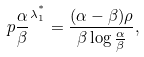<formula> <loc_0><loc_0><loc_500><loc_500>\ p { \frac { \alpha } { \beta } } ^ { \lambda _ { 1 } ^ { ^ { * } } } = \frac { ( \alpha - \beta ) \rho } { \beta \log \frac { \alpha } { \beta } } ,</formula> 